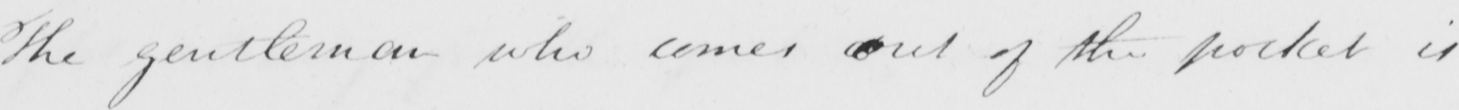Please transcribe the handwritten text in this image. The gentleman who comes out of the pocket is 